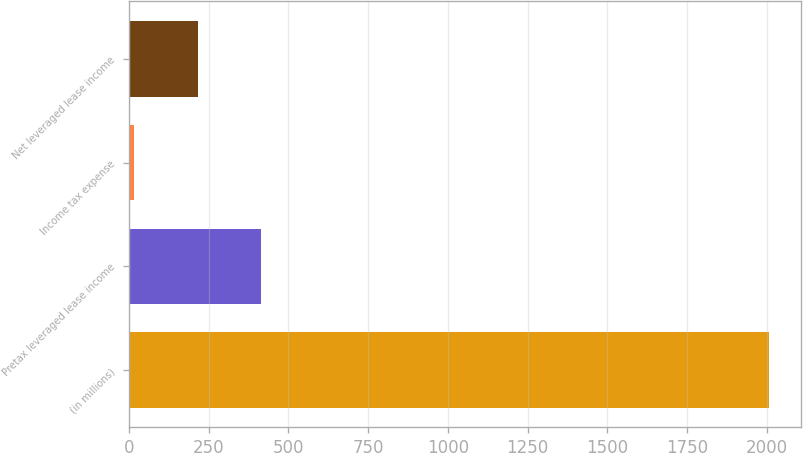Convert chart. <chart><loc_0><loc_0><loc_500><loc_500><bar_chart><fcel>(in millions)<fcel>Pretax leveraged lease income<fcel>Income tax expense<fcel>Net leveraged lease income<nl><fcel>2006<fcel>414.8<fcel>17<fcel>215.9<nl></chart> 